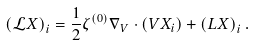<formula> <loc_0><loc_0><loc_500><loc_500>\left ( \mathcal { L } X \right ) _ { i } = \frac { 1 } { 2 } \zeta ^ { ( 0 ) } \nabla _ { V } \cdot \left ( V X _ { i } \right ) + \left ( L X \right ) _ { i } .</formula> 